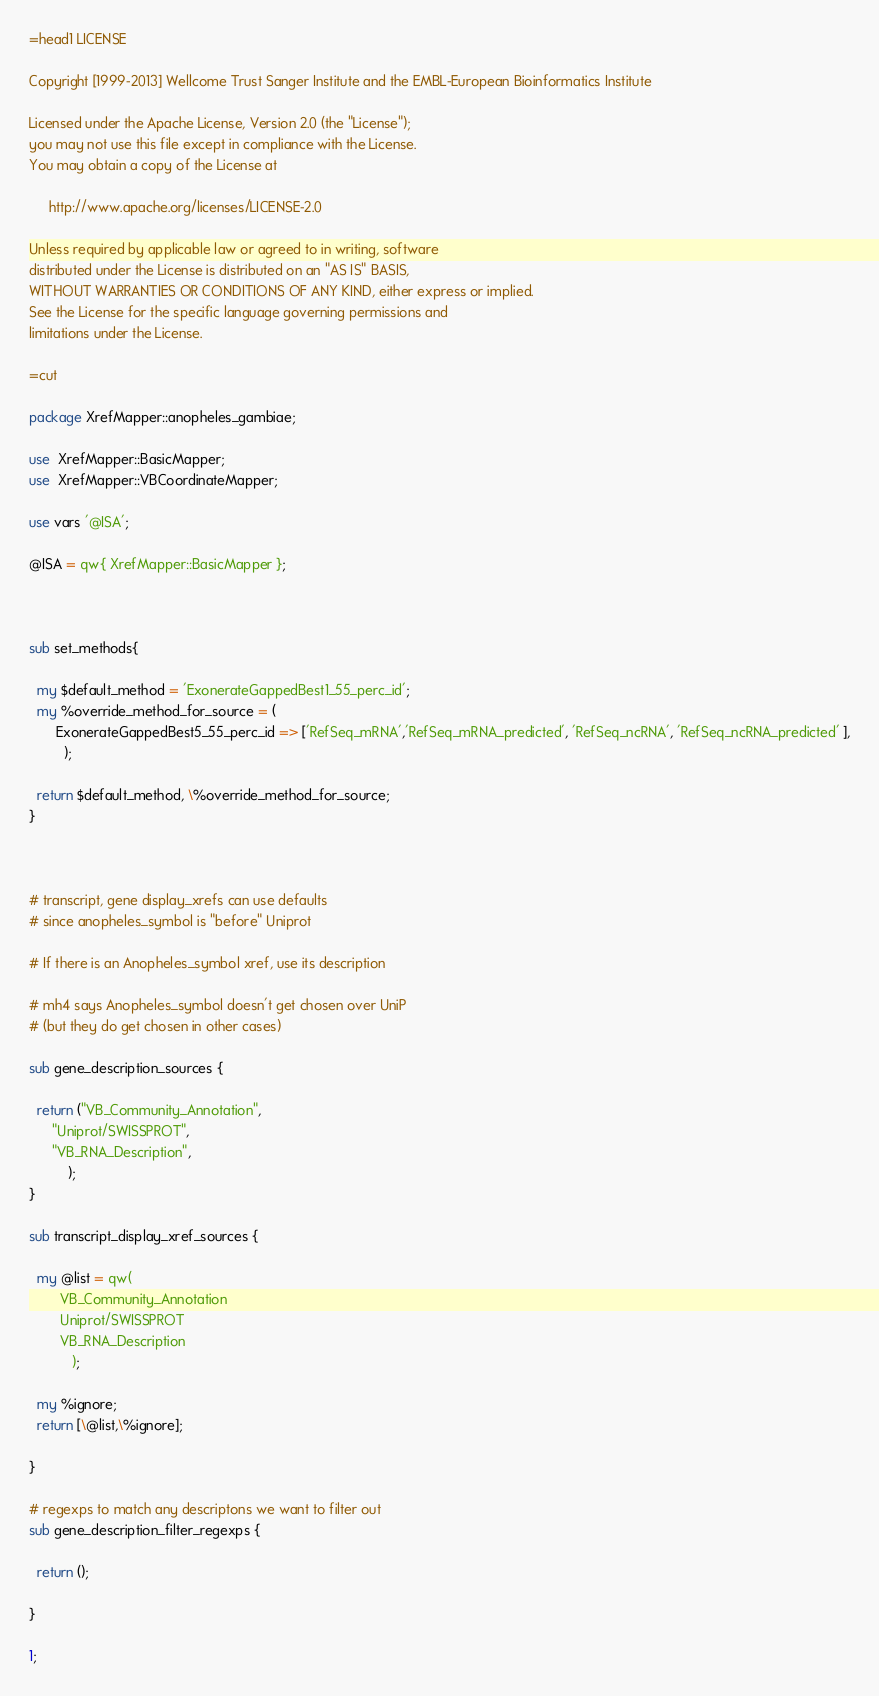Convert code to text. <code><loc_0><loc_0><loc_500><loc_500><_Perl_>=head1 LICENSE

Copyright [1999-2013] Wellcome Trust Sanger Institute and the EMBL-European Bioinformatics Institute

Licensed under the Apache License, Version 2.0 (the "License");
you may not use this file except in compliance with the License.
You may obtain a copy of the License at

     http://www.apache.org/licenses/LICENSE-2.0

Unless required by applicable law or agreed to in writing, software
distributed under the License is distributed on an "AS IS" BASIS,
WITHOUT WARRANTIES OR CONDITIONS OF ANY KIND, either express or implied.
See the License for the specific language governing permissions and
limitations under the License.

=cut

package XrefMapper::anopheles_gambiae;

use  XrefMapper::BasicMapper;
use  XrefMapper::VBCoordinateMapper;

use vars '@ISA';

@ISA = qw{ XrefMapper::BasicMapper };



sub set_methods{
 
  my $default_method = 'ExonerateGappedBest1_55_perc_id';
  my %override_method_for_source = (  
	   ExonerateGappedBest5_55_perc_id => ['RefSeq_mRNA','RefSeq_mRNA_predicted', 'RefSeq_ncRNA', 'RefSeq_ncRNA_predicted' ],
         );

  return $default_method, \%override_method_for_source;
}



# transcript, gene display_xrefs can use defaults
# since anopheles_symbol is "before" Uniprot

# If there is an Anopheles_symbol xref, use its description

# mh4 says Anopheles_symbol doesn't get chosen over UniP
# (but they do get chosen in other cases)

sub gene_description_sources {

  return ("VB_Community_Annotation",
	  "Uniprot/SWISSPROT",
	  "VB_RNA_Description",
          );
}

sub transcript_display_xref_sources {

  my @list = qw(
		VB_Community_Annotation
		Uniprot/SWISSPROT
		VB_RNA_Description
	       );

  my %ignore;
  return [\@list,\%ignore];

}

# regexps to match any descriptons we want to filter out
sub gene_description_filter_regexps {

  return ();

}

1;
</code> 